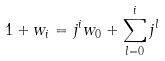Convert formula to latex. <formula><loc_0><loc_0><loc_500><loc_500>1 + w _ { i } = j ^ { i } w _ { 0 } + \sum _ { l = 0 } ^ { i } j ^ { l }</formula> 